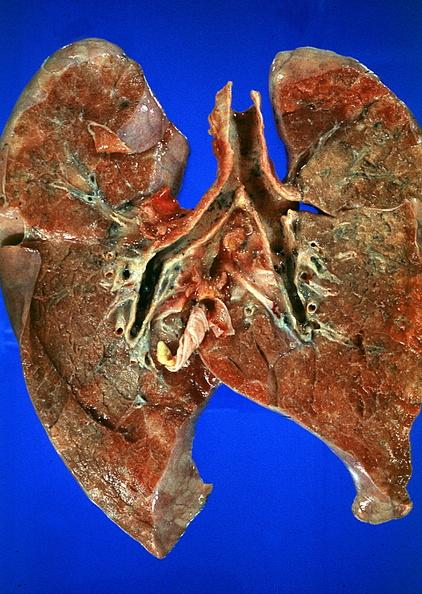do meningitis purulent burn smoke inhalation?
Answer the question using a single word or phrase. No 